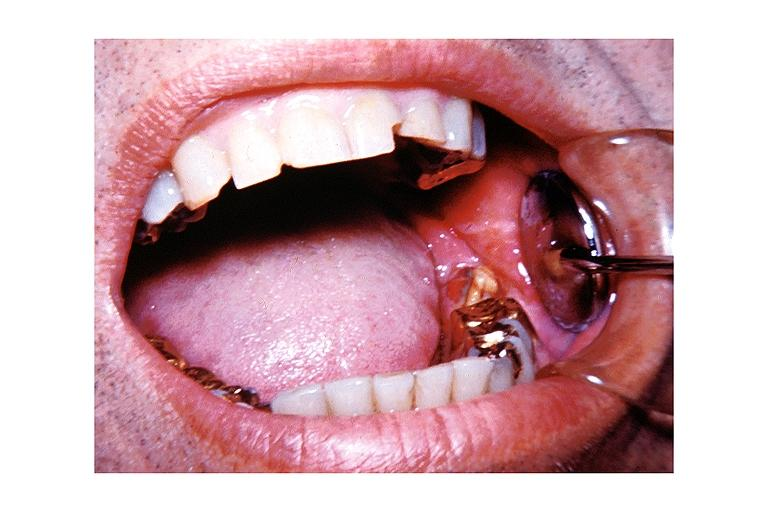s frontal slab of liver present?
Answer the question using a single word or phrase. No 